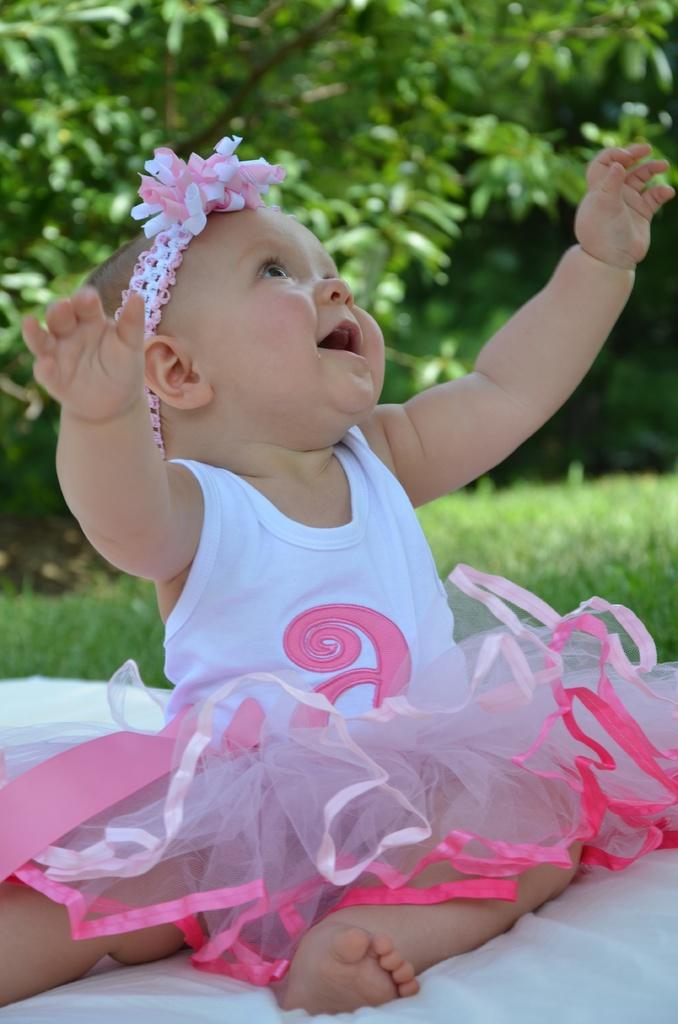Who is the main subject in the image? There is a girl in the image. What is the girl sitting on? The girl is sitting on a cloth. What can be seen in the background of the image? There is grass and trees in the background of the image. What type of market can be seen in the image? There is no market present in the image; it features a girl sitting on a cloth with grass and trees in the background. 